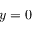<formula> <loc_0><loc_0><loc_500><loc_500>y = 0</formula> 